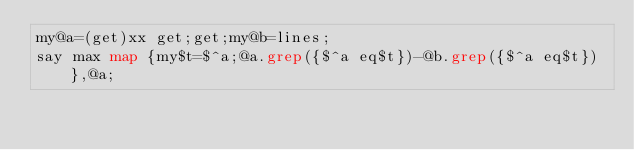<code> <loc_0><loc_0><loc_500><loc_500><_Perl_>my@a=(get)xx get;get;my@b=lines;
say max map {my$t=$^a;@a.grep({$^a eq$t})-@b.grep({$^a eq$t})},@a;</code> 